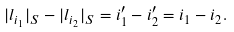<formula> <loc_0><loc_0><loc_500><loc_500>| l _ { i _ { 1 } } | _ { S } - | l _ { i _ { 2 } } | _ { S } = i _ { 1 } ^ { \prime } - i _ { 2 } ^ { \prime } = i _ { 1 } - i _ { 2 } .</formula> 